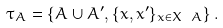Convert formula to latex. <formula><loc_0><loc_0><loc_500><loc_500>\tau _ { A } = \left \{ A \cup A ^ { \prime } , \{ x , x ^ { \prime } \} _ { x \in X \ A } \right \} .</formula> 